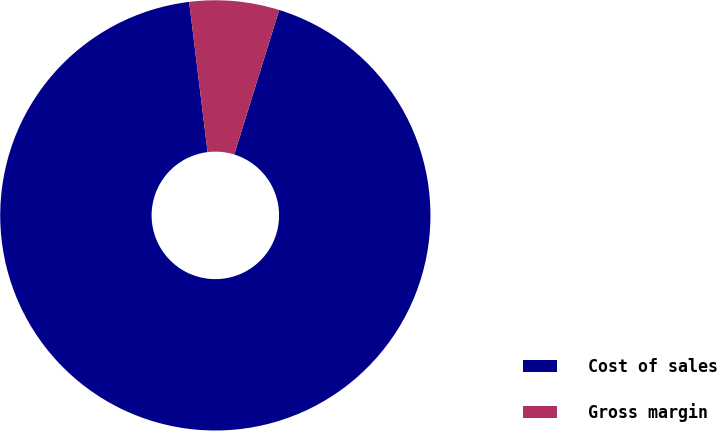Convert chart to OTSL. <chart><loc_0><loc_0><loc_500><loc_500><pie_chart><fcel>Cost of sales<fcel>Gross margin<nl><fcel>93.26%<fcel>6.74%<nl></chart> 